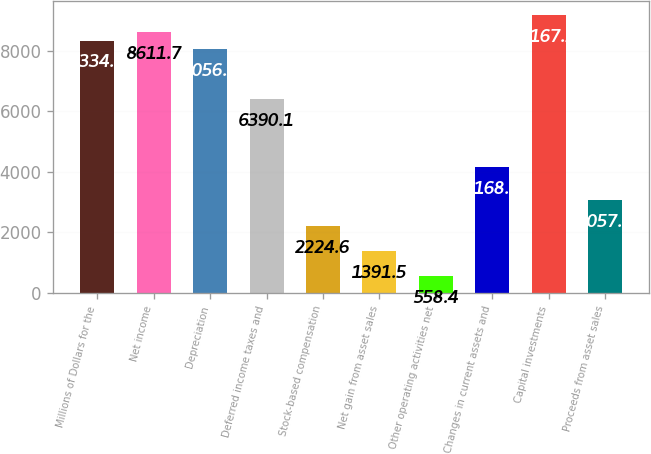<chart> <loc_0><loc_0><loc_500><loc_500><bar_chart><fcel>Millions of Dollars for the<fcel>Net income<fcel>Depreciation<fcel>Deferred income taxes and<fcel>Stock-based compensation<fcel>Net gain from asset sales<fcel>Other operating activities net<fcel>Changes in current assets and<fcel>Capital investments<fcel>Proceeds from asset sales<nl><fcel>8334<fcel>8611.7<fcel>8056.3<fcel>6390.1<fcel>2224.6<fcel>1391.5<fcel>558.4<fcel>4168.5<fcel>9167.1<fcel>3057.7<nl></chart> 